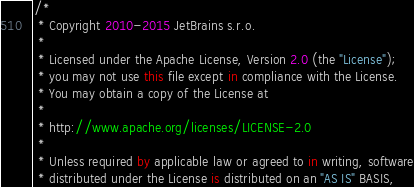Convert code to text. <code><loc_0><loc_0><loc_500><loc_500><_Kotlin_>/*
 * Copyright 2010-2015 JetBrains s.r.o.
 *
 * Licensed under the Apache License, Version 2.0 (the "License");
 * you may not use this file except in compliance with the License.
 * You may obtain a copy of the License at
 *
 * http://www.apache.org/licenses/LICENSE-2.0
 *
 * Unless required by applicable law or agreed to in writing, software
 * distributed under the License is distributed on an "AS IS" BASIS,</code> 